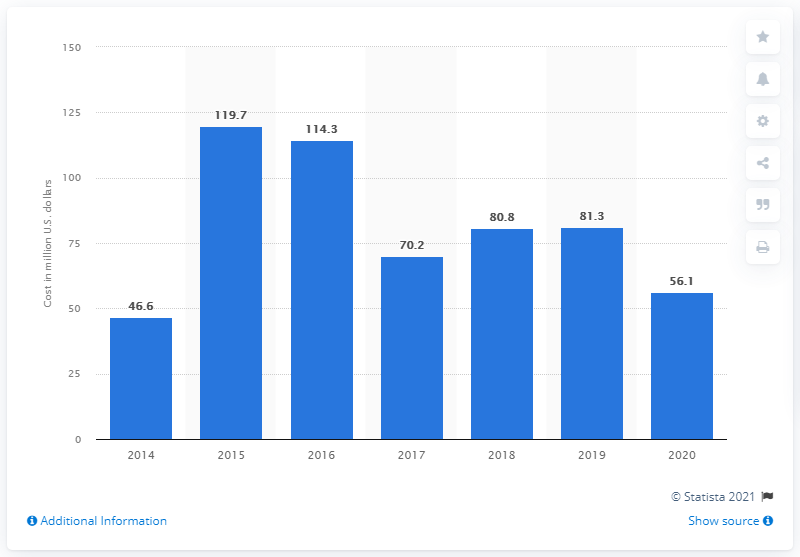List a handful of essential elements in this visual. In the previous fiscal year, Twitter spent approximately 81.3 million dollars on advertising. Twitter invested $56.1 million in advertising during the most recent fiscal year. 